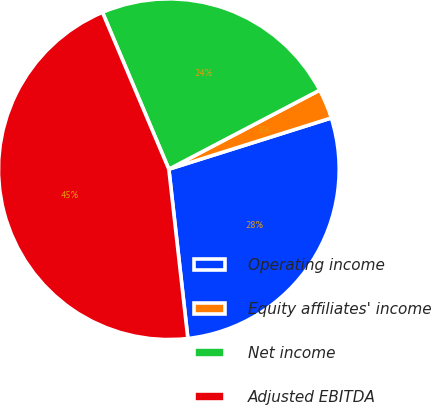<chart> <loc_0><loc_0><loc_500><loc_500><pie_chart><fcel>Operating income<fcel>Equity affiliates' income<fcel>Net income<fcel>Adjusted EBITDA<nl><fcel>28.08%<fcel>2.82%<fcel>23.69%<fcel>45.41%<nl></chart> 